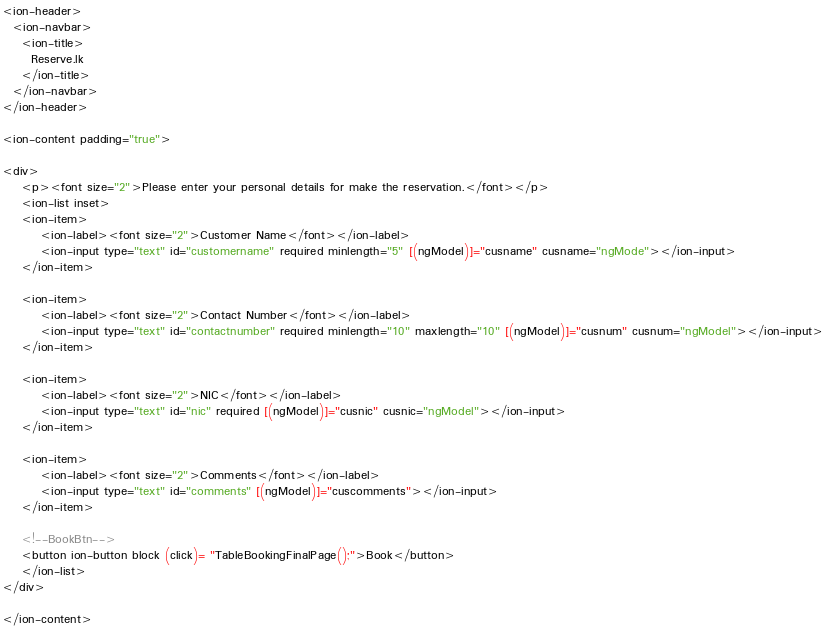Convert code to text. <code><loc_0><loc_0><loc_500><loc_500><_HTML_><ion-header>
  <ion-navbar>
    <ion-title>
      Reserve.lk
    </ion-title>
  </ion-navbar>
</ion-header>

<ion-content padding="true">

<div>
    <p><font size="2">Please enter your personal details for make the reservation.</font></p>
    <ion-list inset>
    <ion-item>
        <ion-label><font size="2">Customer Name</font></ion-label>
        <ion-input type="text" id="customername" required minlength="5" [(ngModel)]="cusname" cusname="ngMode"></ion-input>
    </ion-item>

    <ion-item>
        <ion-label><font size="2">Contact Number</font></ion-label>
        <ion-input type="text" id="contactnumber" required minlength="10" maxlength="10" [(ngModel)]="cusnum" cusnum="ngModel"></ion-input>
    </ion-item>

    <ion-item>
        <ion-label><font size="2">NIC</font></ion-label>
        <ion-input type="text" id="nic" required [(ngModel)]="cusnic" cusnic="ngModel"></ion-input>
    </ion-item>

    <ion-item>
        <ion-label><font size="2">Comments</font></ion-label>
        <ion-input type="text" id="comments" [(ngModel)]="cuscomments"></ion-input>
    </ion-item>

    <!--BookBtn-->
    <button ion-button block (click)= "TableBookingFinalPage();">Book</button>
    </ion-list>
</div>

</ion-content>

</code> 